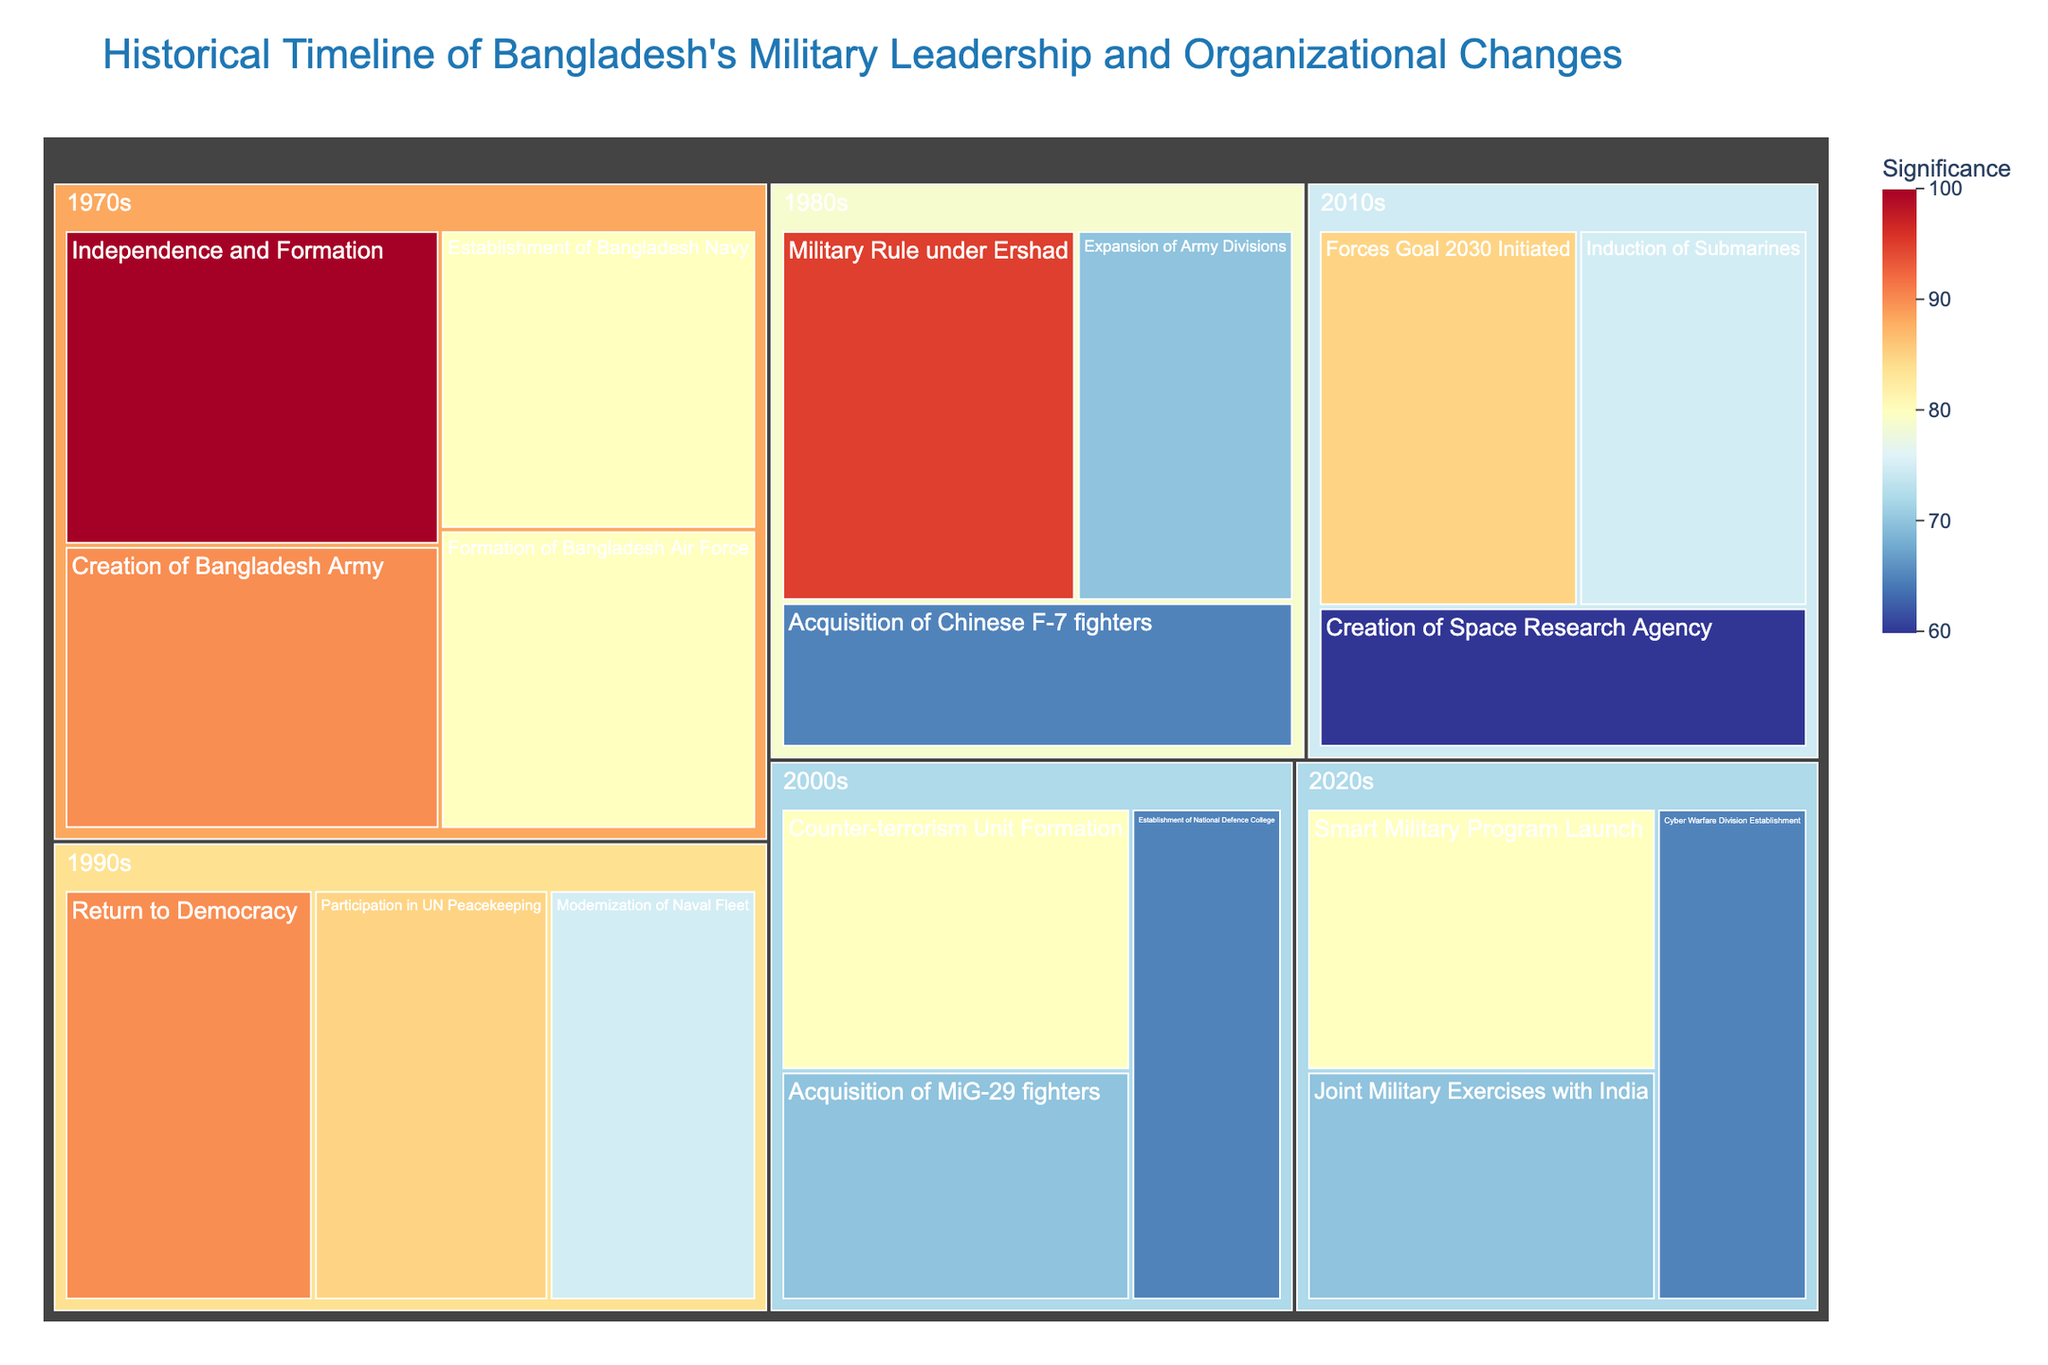How is the color scale represented in the treemap? The treemap uses a color scale ranging from blue to red where cooler colors (blue) signify lower significance values and warmer colors (red) represent higher significance values.
Answer: Blue to red color scale What is the most significant event in the 1970s according to the treemap? By examining the size and color intensity of the boxes in the decade of the 1970s, "Independence and Formation" stands out as the most significant event.
Answer: Independence and Formation Which decade had the highest number of significant events? To determine this, look at which decade has the most boxes representing events. The decades can be visually compared by counting the boxes within each decade.
Answer: 2010s and 2020s (with 3 events each) How does the significance of "Military Rule under Ershad" in the 1980s compare to "Return to Democracy" in the 1990s? "Military Rule under Ershad" in the 1980s has a significance value of 95, while "Return to Democracy" in the 1990s has a significance value of 90, indicating that the former is slightly more significant.
Answer: Military Rule under Ershad is slightly more significant Which decade saw the initiation of the "Forces Goal 2030"? The "Forces Goal 2030" can be identified in the treemap by examining the text labels within the boxes; it is located in the 2010s decade.
Answer: 2010s What is the combined significance value of all significant events in the 1990s? To find the combined significance for the 1990s, sum up the significance values of all events in that decade: 90 (Return to Democracy) + 85 (Participation in UN Peacekeeping) + 75 (Modernization of Naval Fleet) = 250.
Answer: 250 Which events in the 2000s have the same significance value, and what is that value? By referring to the boxes within the 2000s decade, "Counter-terrorism Unit Formation" and "Acquisition of MiG-29 fighters" have the same significance value, both at 70.
Answer: Counter-terrorism Unit Formation and Acquisition of MiG-29 fighters; value: 70 What new military capability was established in the 2020s focusing on modern security threats? The treemap shows a box labeled "Cyber Warfare Division Establishment" within the 2020s, indicating a focus on modern security threats.
Answer: Cyber Warfare Division Establishment Which specific event in the 2010s could be related to technological advancements beyond traditional military capabilities? "Creation of Space Research Agency" in the 2010s decade is an event related to technological advancements beyond traditional military capabilities.
Answer: Creation of Space Research Agency 